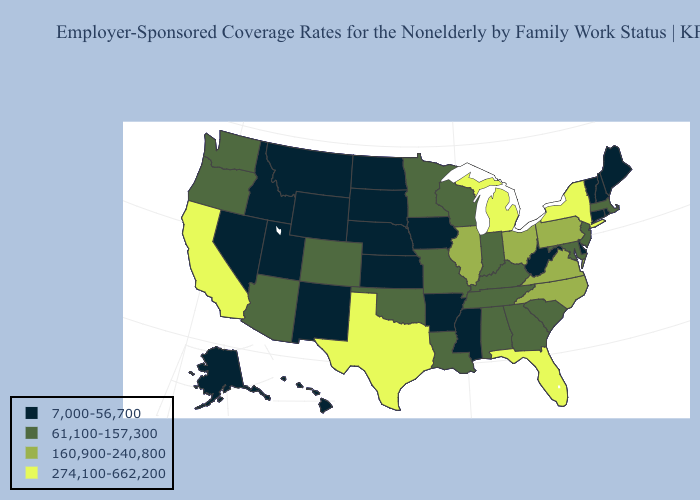What is the value of Virginia?
Be succinct. 160,900-240,800. Does New Jersey have the lowest value in the Northeast?
Answer briefly. No. Name the states that have a value in the range 7,000-56,700?
Answer briefly. Alaska, Arkansas, Connecticut, Delaware, Hawaii, Idaho, Iowa, Kansas, Maine, Mississippi, Montana, Nebraska, Nevada, New Hampshire, New Mexico, North Dakota, Rhode Island, South Dakota, Utah, Vermont, West Virginia, Wyoming. What is the lowest value in the South?
Keep it brief. 7,000-56,700. What is the value of Utah?
Concise answer only. 7,000-56,700. What is the value of South Carolina?
Keep it brief. 61,100-157,300. Name the states that have a value in the range 160,900-240,800?
Concise answer only. Illinois, North Carolina, Ohio, Pennsylvania, Virginia. Among the states that border South Carolina , does North Carolina have the highest value?
Give a very brief answer. Yes. Is the legend a continuous bar?
Write a very short answer. No. Name the states that have a value in the range 160,900-240,800?
Answer briefly. Illinois, North Carolina, Ohio, Pennsylvania, Virginia. Name the states that have a value in the range 7,000-56,700?
Short answer required. Alaska, Arkansas, Connecticut, Delaware, Hawaii, Idaho, Iowa, Kansas, Maine, Mississippi, Montana, Nebraska, Nevada, New Hampshire, New Mexico, North Dakota, Rhode Island, South Dakota, Utah, Vermont, West Virginia, Wyoming. Name the states that have a value in the range 7,000-56,700?
Keep it brief. Alaska, Arkansas, Connecticut, Delaware, Hawaii, Idaho, Iowa, Kansas, Maine, Mississippi, Montana, Nebraska, Nevada, New Hampshire, New Mexico, North Dakota, Rhode Island, South Dakota, Utah, Vermont, West Virginia, Wyoming. What is the lowest value in the Northeast?
Answer briefly. 7,000-56,700. Which states have the lowest value in the MidWest?
Keep it brief. Iowa, Kansas, Nebraska, North Dakota, South Dakota. What is the lowest value in the MidWest?
Concise answer only. 7,000-56,700. 